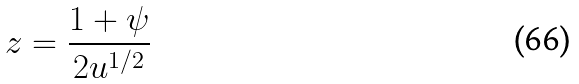<formula> <loc_0><loc_0><loc_500><loc_500>z = \frac { 1 + \psi } { 2 u ^ { 1 / 2 } }</formula> 